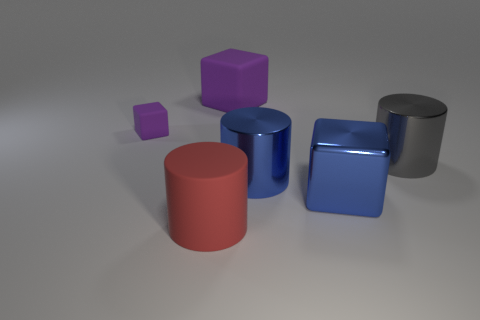Subtract all big blue metallic cubes. How many cubes are left? 2 Add 4 big purple rubber blocks. How many objects exist? 10 Subtract 3 cubes. How many cubes are left? 0 Subtract all gray cylinders. How many cylinders are left? 2 Subtract all small purple objects. Subtract all big gray metal objects. How many objects are left? 4 Add 4 big gray metal things. How many big gray metal things are left? 5 Add 6 big gray metal things. How many big gray metal things exist? 7 Subtract 0 red cubes. How many objects are left? 6 Subtract all green cubes. Subtract all yellow cylinders. How many cubes are left? 3 Subtract all yellow balls. How many purple blocks are left? 2 